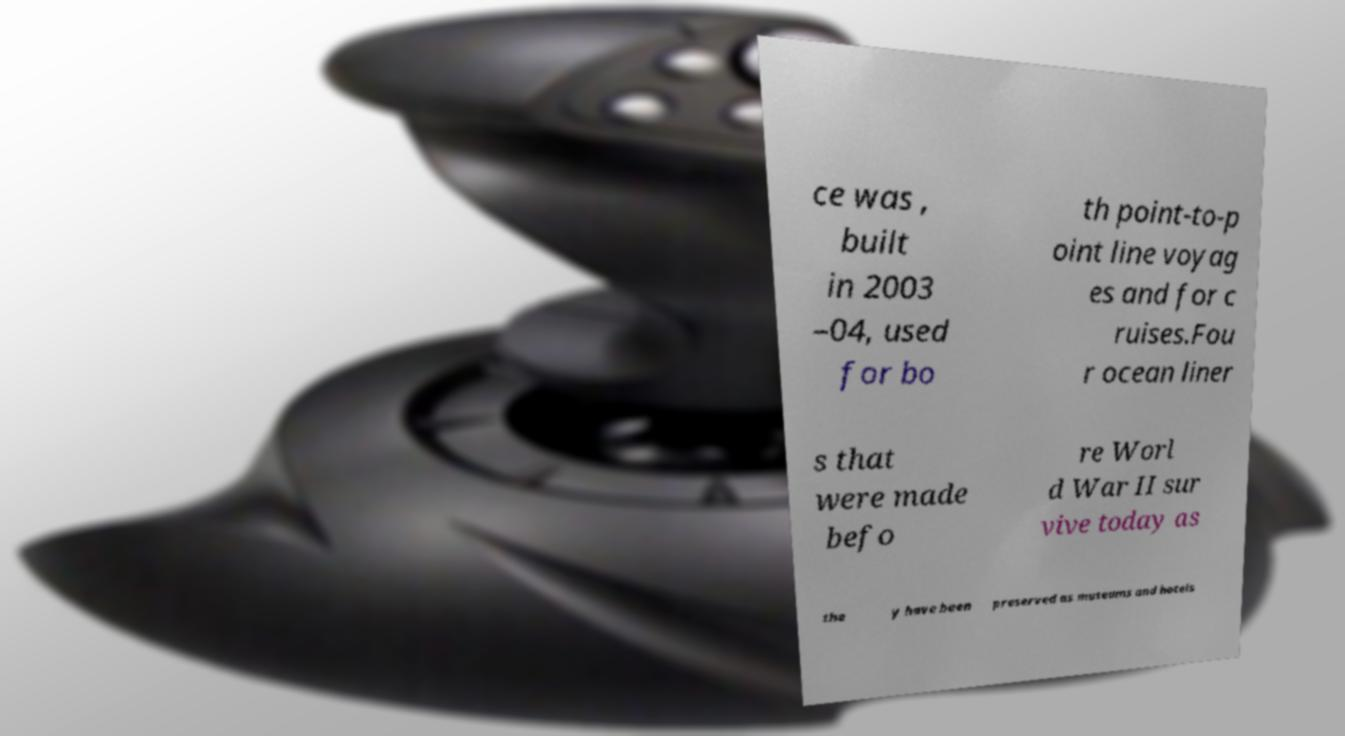There's text embedded in this image that I need extracted. Can you transcribe it verbatim? ce was , built in 2003 –04, used for bo th point-to-p oint line voyag es and for c ruises.Fou r ocean liner s that were made befo re Worl d War II sur vive today as the y have been preserved as museums and hotels 